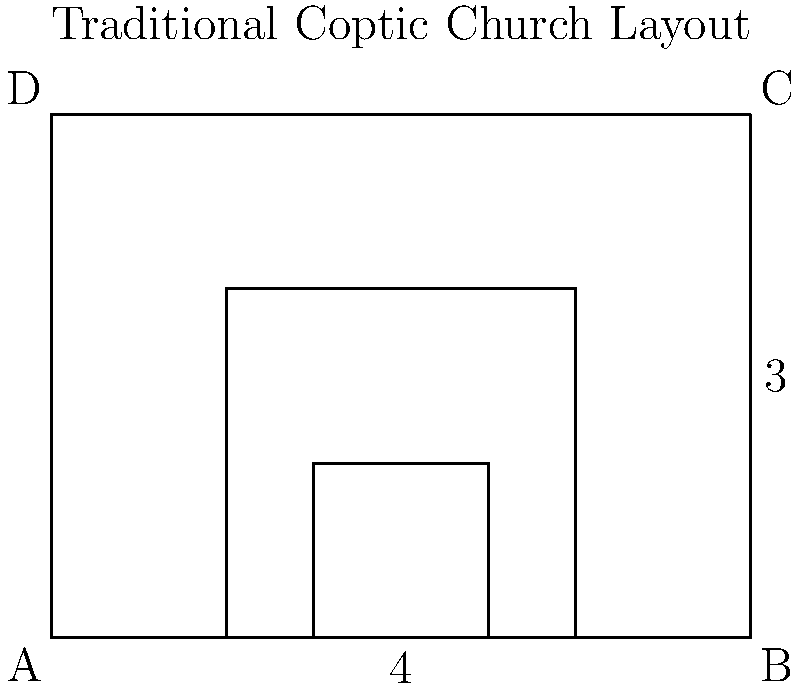In a traditional Coptic church layout, the nave is typically 2/3 the width of the entire church. If the church is scaled up by a factor of 1.5, and the new width of the nave is 6 units, what is the new width of the entire church? Let's approach this step-by-step:

1) First, we know that the nave is 2/3 the width of the entire church. We can express this as an equation:
   $$\text{Nave width} = \frac{2}{3} \times \text{Church width}$$

2) We're told that after scaling, the new nave width is 6 units. Let's call the new church width $x$. Using our equation:
   $$6 = \frac{2}{3}x$$

3) To solve for $x$, we multiply both sides by $\frac{3}{2}$:
   $$6 \times \frac{3}{2} = x$$
   $$9 = x$$

4) So, the new width of the entire church is 9 units.

5) We can verify this: The nave should be 2/3 of 9, which is indeed 6 units.

6) Note that this result is consistent with the scaling factor of 1.5. If we started with a church of width 6 (with a nave of width 4), scaling by 1.5 would indeed give us a church of width 9 with a nave of width 6.

This problem demonstrates how vector scaling affects all dimensions proportionally, maintaining the ratios in the original figure.
Answer: 9 units 